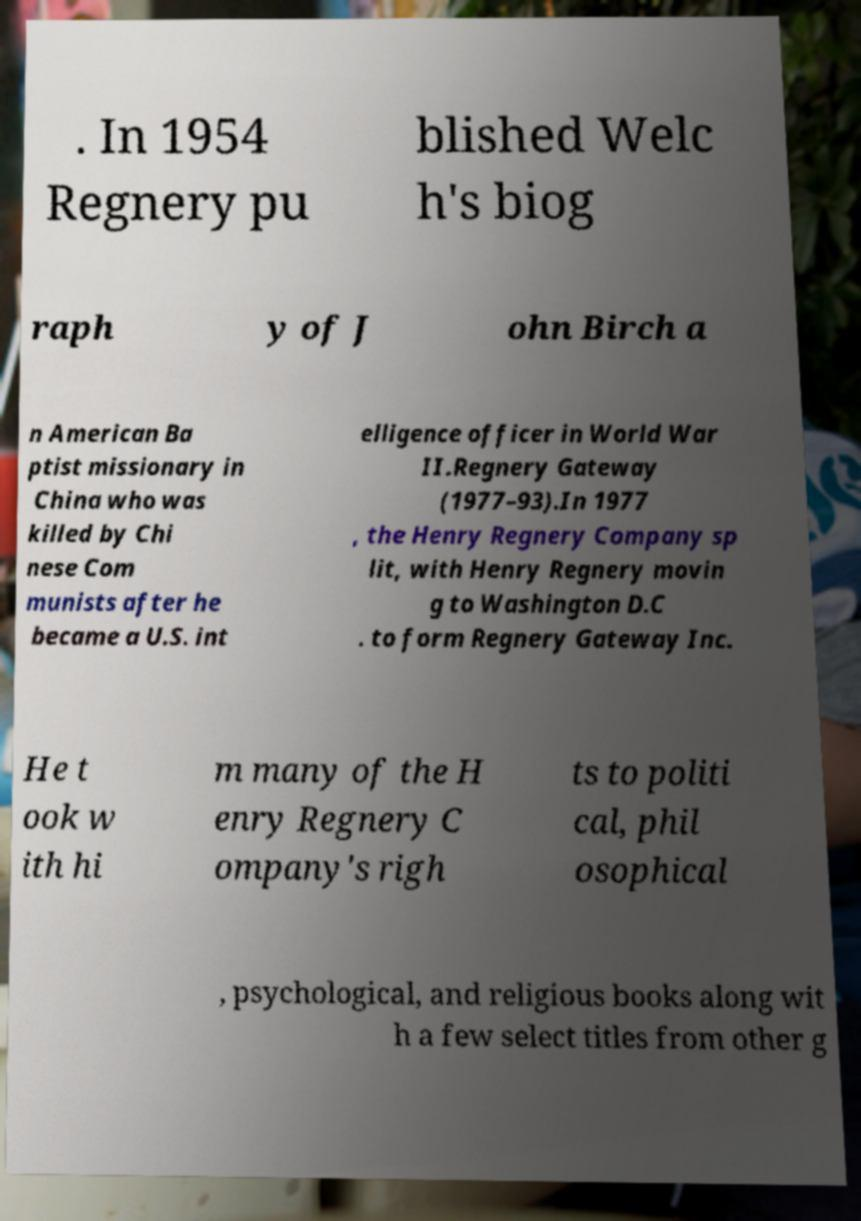There's text embedded in this image that I need extracted. Can you transcribe it verbatim? . In 1954 Regnery pu blished Welc h's biog raph y of J ohn Birch a n American Ba ptist missionary in China who was killed by Chi nese Com munists after he became a U.S. int elligence officer in World War II.Regnery Gateway (1977–93).In 1977 , the Henry Regnery Company sp lit, with Henry Regnery movin g to Washington D.C . to form Regnery Gateway Inc. He t ook w ith hi m many of the H enry Regnery C ompany's righ ts to politi cal, phil osophical , psychological, and religious books along wit h a few select titles from other g 